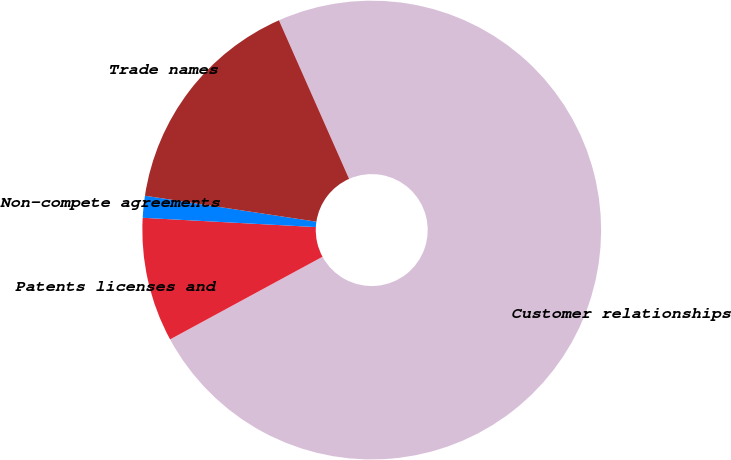Convert chart to OTSL. <chart><loc_0><loc_0><loc_500><loc_500><pie_chart><fcel>Customer relationships<fcel>Patents licenses and<fcel>Non-compete agreements<fcel>Trade names<nl><fcel>73.73%<fcel>8.76%<fcel>1.54%<fcel>15.98%<nl></chart> 